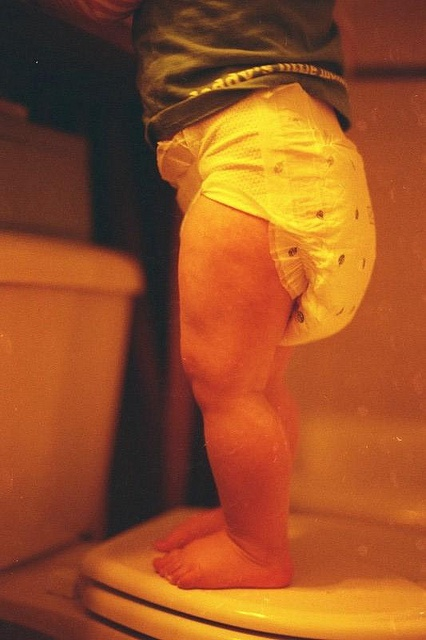Describe the objects in this image and their specific colors. I can see people in black, red, orange, maroon, and gold tones and toilet in black, brown, red, maroon, and orange tones in this image. 